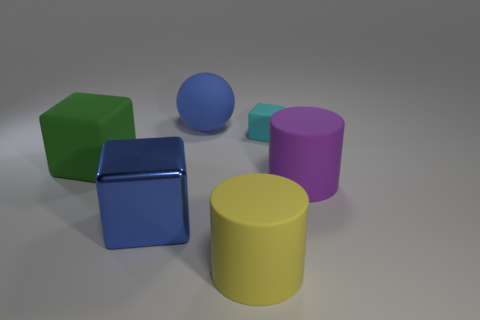Subtract all rubber cubes. How many cubes are left? 1 Add 2 large cyan metallic spheres. How many objects exist? 8 Subtract all green cubes. How many cubes are left? 2 Subtract 2 blocks. How many blocks are left? 1 Subtract all cylinders. How many objects are left? 4 Subtract all metal blocks. Subtract all blue metallic cylinders. How many objects are left? 5 Add 4 matte cylinders. How many matte cylinders are left? 6 Add 1 green cubes. How many green cubes exist? 2 Subtract 0 yellow blocks. How many objects are left? 6 Subtract all purple cylinders. Subtract all cyan spheres. How many cylinders are left? 1 